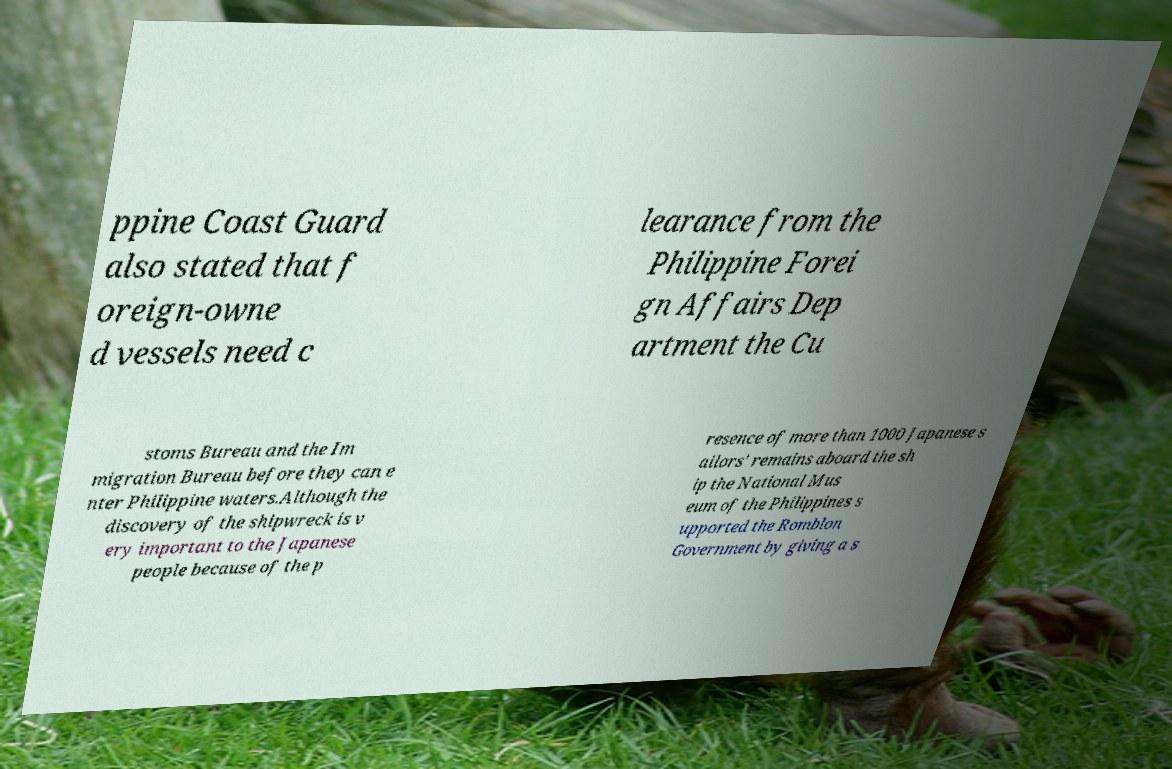For documentation purposes, I need the text within this image transcribed. Could you provide that? ppine Coast Guard also stated that f oreign-owne d vessels need c learance from the Philippine Forei gn Affairs Dep artment the Cu stoms Bureau and the Im migration Bureau before they can e nter Philippine waters.Although the discovery of the shipwreck is v ery important to the Japanese people because of the p resence of more than 1000 Japanese s ailors' remains aboard the sh ip the National Mus eum of the Philippines s upported the Romblon Government by giving a s 